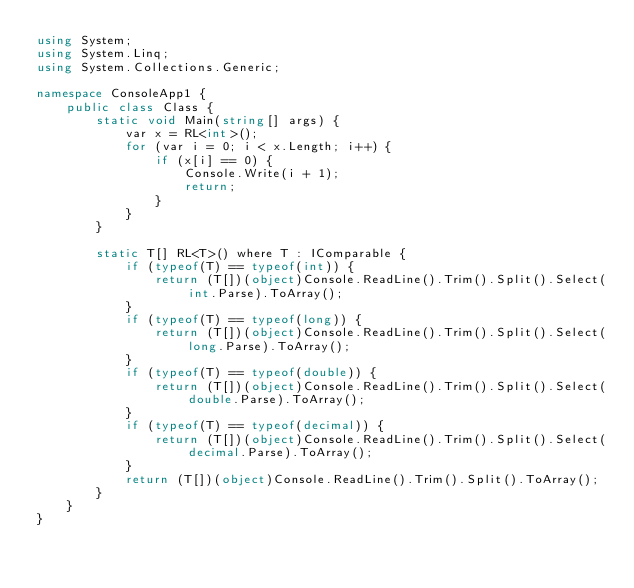<code> <loc_0><loc_0><loc_500><loc_500><_C#_>using System;
using System.Linq;
using System.Collections.Generic;

namespace ConsoleApp1 {
    public class Class {
        static void Main(string[] args) {
            var x = RL<int>();
            for (var i = 0; i < x.Length; i++) {
                if (x[i] == 0) {
                    Console.Write(i + 1);
                    return;
                }
            }
        }

        static T[] RL<T>() where T : IComparable {
            if (typeof(T) == typeof(int)) {
                return (T[])(object)Console.ReadLine().Trim().Split().Select(int.Parse).ToArray();
            }
            if (typeof(T) == typeof(long)) {
                return (T[])(object)Console.ReadLine().Trim().Split().Select(long.Parse).ToArray();
            }
            if (typeof(T) == typeof(double)) {
                return (T[])(object)Console.ReadLine().Trim().Split().Select(double.Parse).ToArray();
            }
            if (typeof(T) == typeof(decimal)) {
                return (T[])(object)Console.ReadLine().Trim().Split().Select(decimal.Parse).ToArray();
            }
            return (T[])(object)Console.ReadLine().Trim().Split().ToArray();
        }
    }
}</code> 